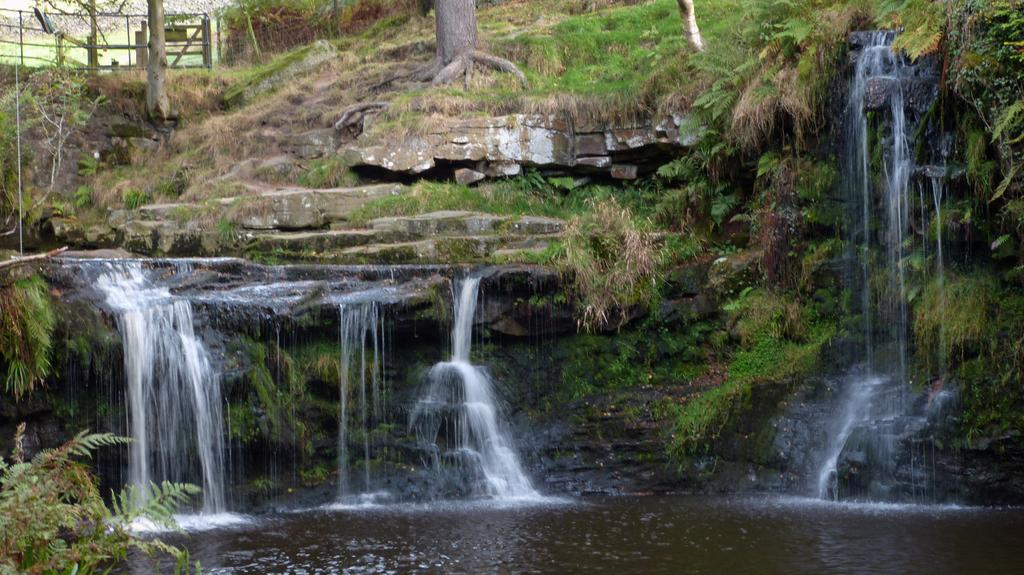What type of vegetation can be seen in the image? There are plants, trees, and grass in the image. What natural feature is located in the middle of the image? There is a waterfall in the middle of the image. What type of lunch is being served at the coach in the image? There is no coach or lunch present in the image; it features plants, trees, grass, and a waterfall. Can you see a robin perched on any of the branches in the image? There is no robin present in the image. 